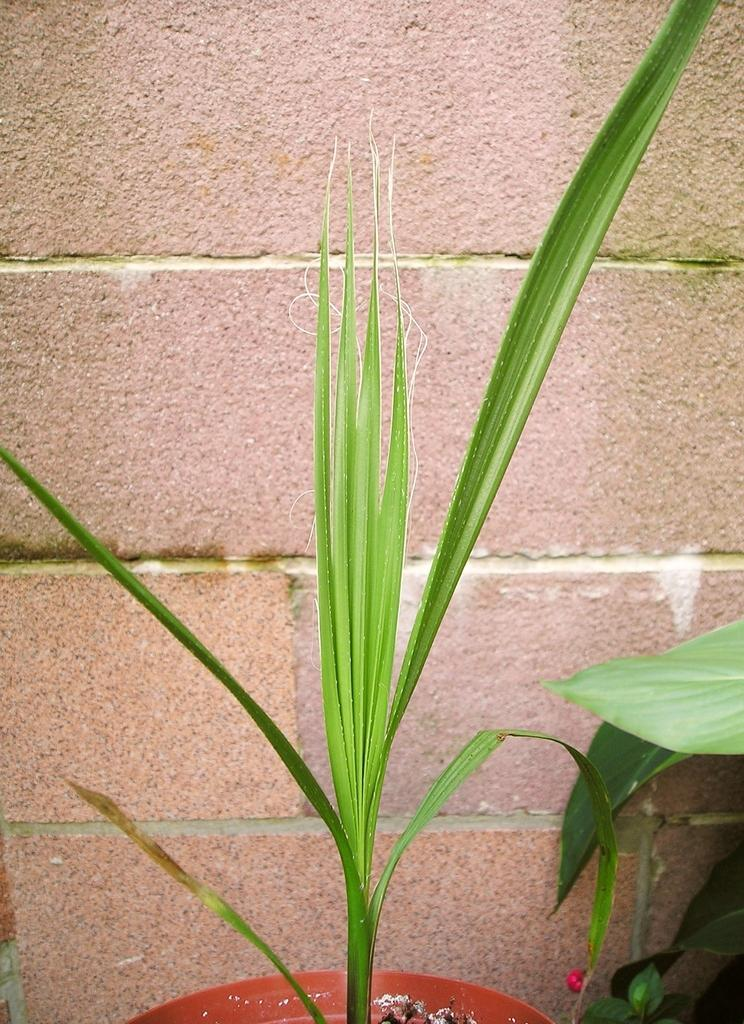What type of plant can be seen in the image? There is a potted plant in the image. Where is the potted plant located in relation to other objects or structures? The potted plant is in front of a wall. What type of business or organization is depicted in the image? There is no business or organization depicted in the image; it only features a potted plant in front of a wall. 